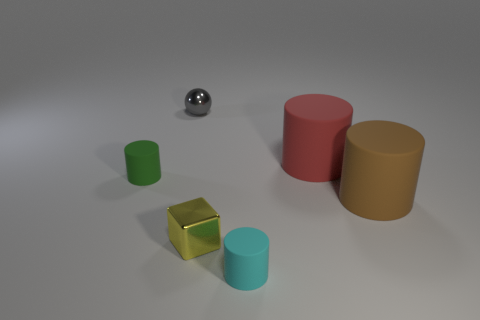Subtract all green spheres. Subtract all blue cylinders. How many spheres are left? 1 Add 2 big matte cylinders. How many objects exist? 8 Subtract all balls. How many objects are left? 5 Add 5 small cyan rubber cylinders. How many small cyan rubber cylinders are left? 6 Add 6 cyan cubes. How many cyan cubes exist? 6 Subtract 0 red spheres. How many objects are left? 6 Subtract all tiny gray metal things. Subtract all large gray metallic objects. How many objects are left? 5 